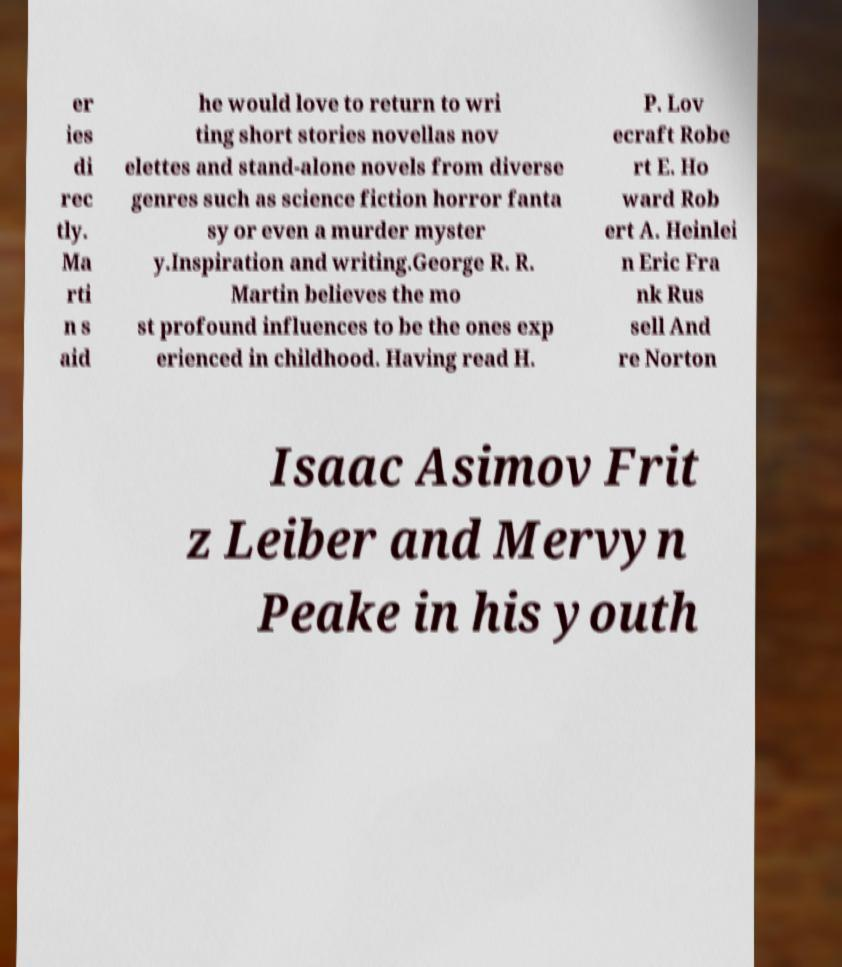What messages or text are displayed in this image? I need them in a readable, typed format. er ies di rec tly. Ma rti n s aid he would love to return to wri ting short stories novellas nov elettes and stand-alone novels from diverse genres such as science fiction horror fanta sy or even a murder myster y.Inspiration and writing.George R. R. Martin believes the mo st profound influences to be the ones exp erienced in childhood. Having read H. P. Lov ecraft Robe rt E. Ho ward Rob ert A. Heinlei n Eric Fra nk Rus sell And re Norton Isaac Asimov Frit z Leiber and Mervyn Peake in his youth 